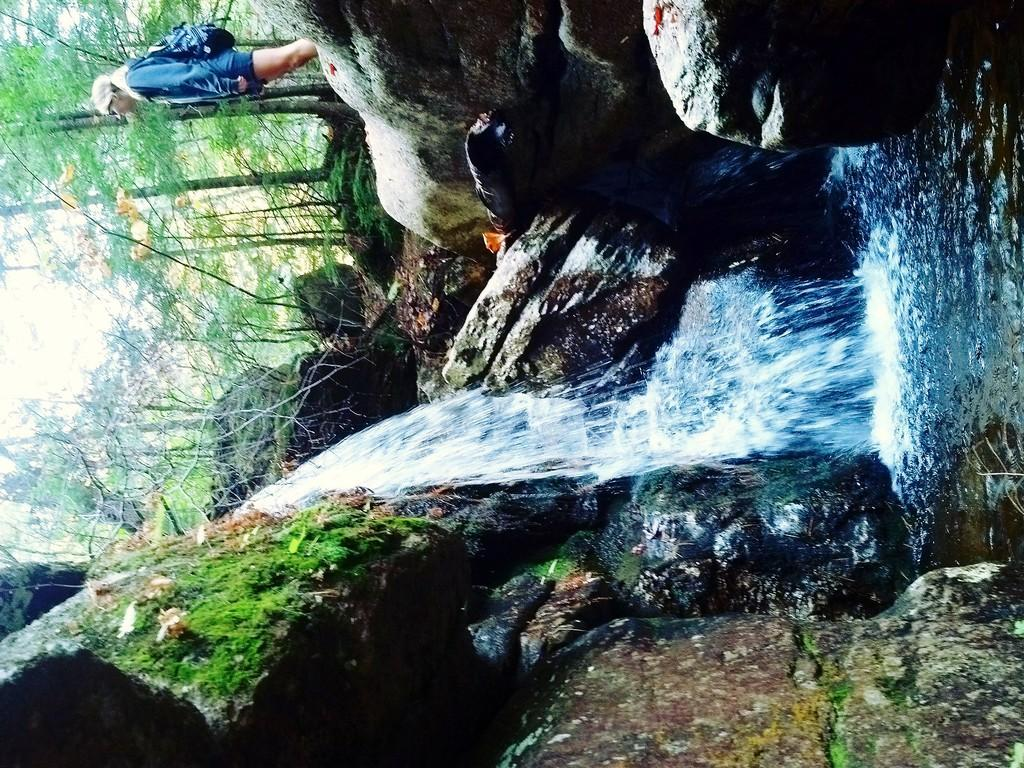What is the person in the image standing on? The person is standing on a rock. What is in front of the person? There is a waterfall in front of the person. What type of vegetation is located near the waterfall? Trees are located beside the waterfall. What type of soda is the person holding in the image? There is no soda present in the image; the person is standing on a rock with a waterfall in front of them and trees beside the waterfall. 